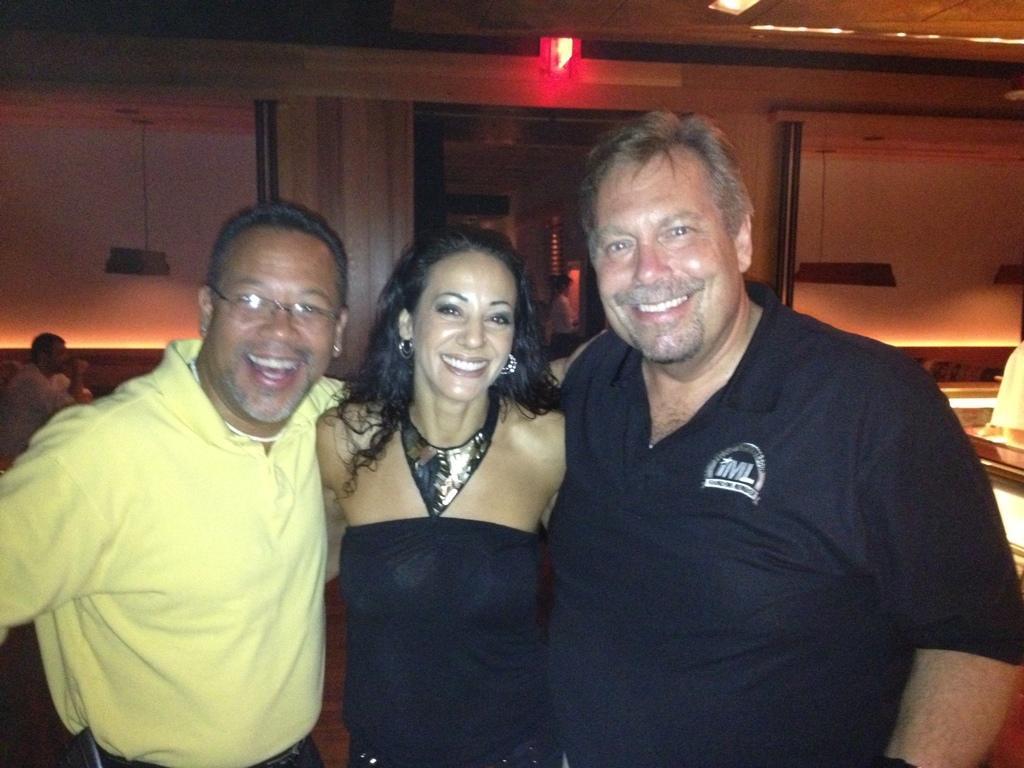Can you describe this image briefly? In this image, there are three persons wearing clothes and standing in front of the wall. There is a person in the right side of the image wearing spectacles. There is a light at the top of the image. 